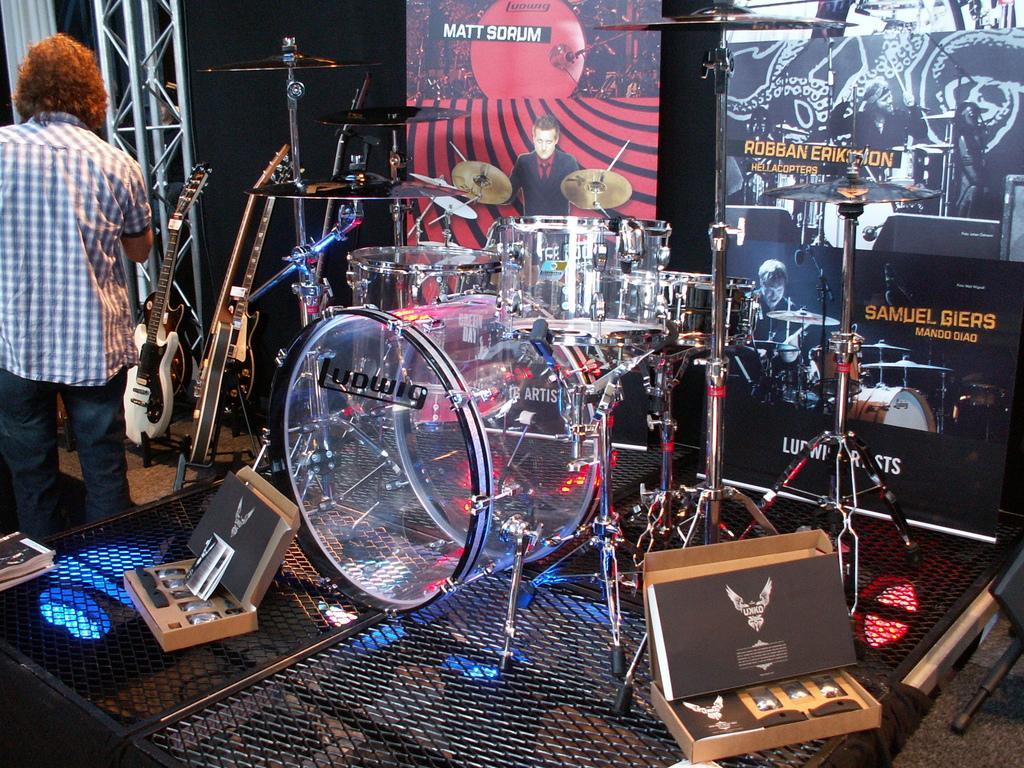Please provide a concise description of this image. In this picture I can observe drums placed on the floor. There is a person standing on the left side. In the background I can observe posters. On the left side I can observe white color curtain. 